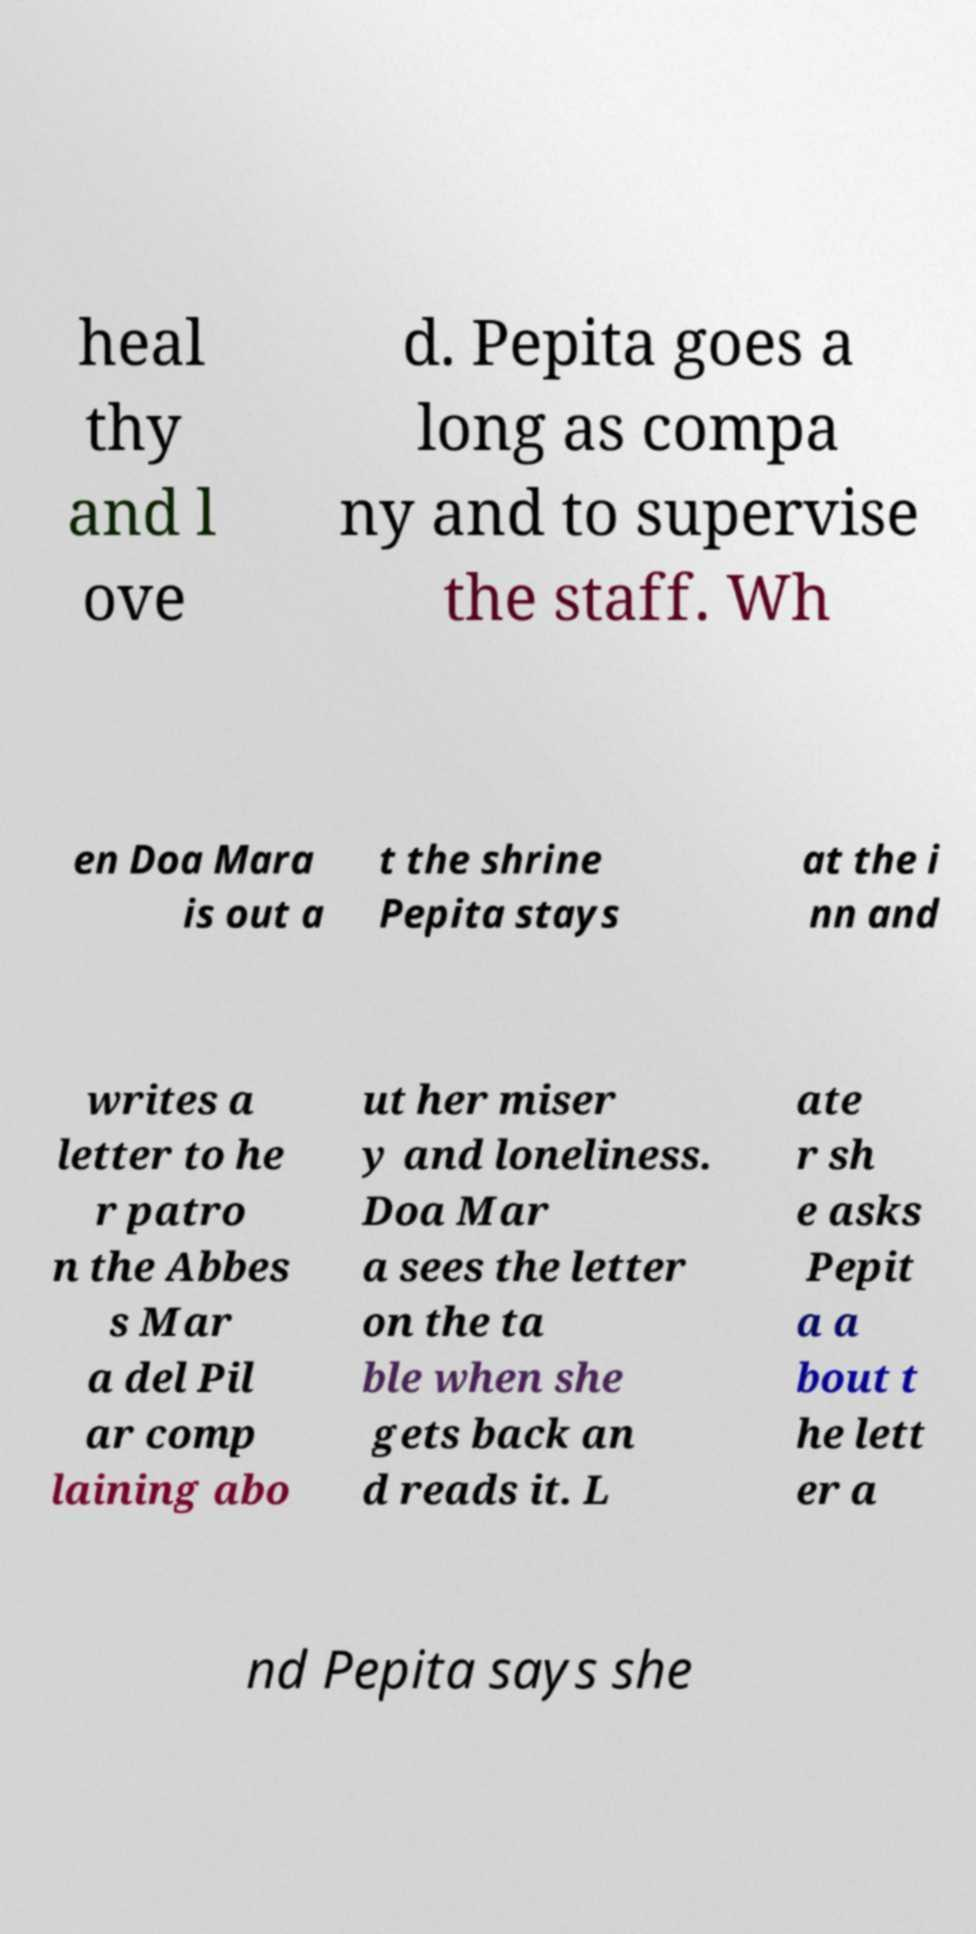I need the written content from this picture converted into text. Can you do that? heal thy and l ove d. Pepita goes a long as compa ny and to supervise the staff. Wh en Doa Mara is out a t the shrine Pepita stays at the i nn and writes a letter to he r patro n the Abbes s Mar a del Pil ar comp laining abo ut her miser y and loneliness. Doa Mar a sees the letter on the ta ble when she gets back an d reads it. L ate r sh e asks Pepit a a bout t he lett er a nd Pepita says she 